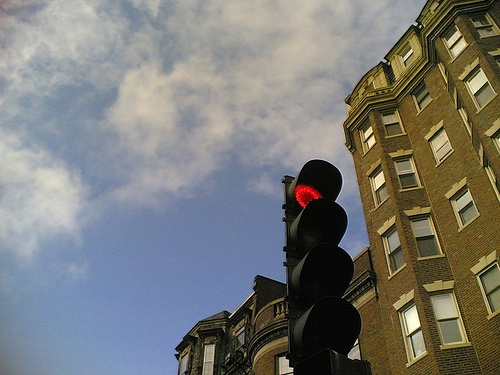Describe the objects in this image and their specific colors. I can see a traffic light in gray, black, and maroon tones in this image. 